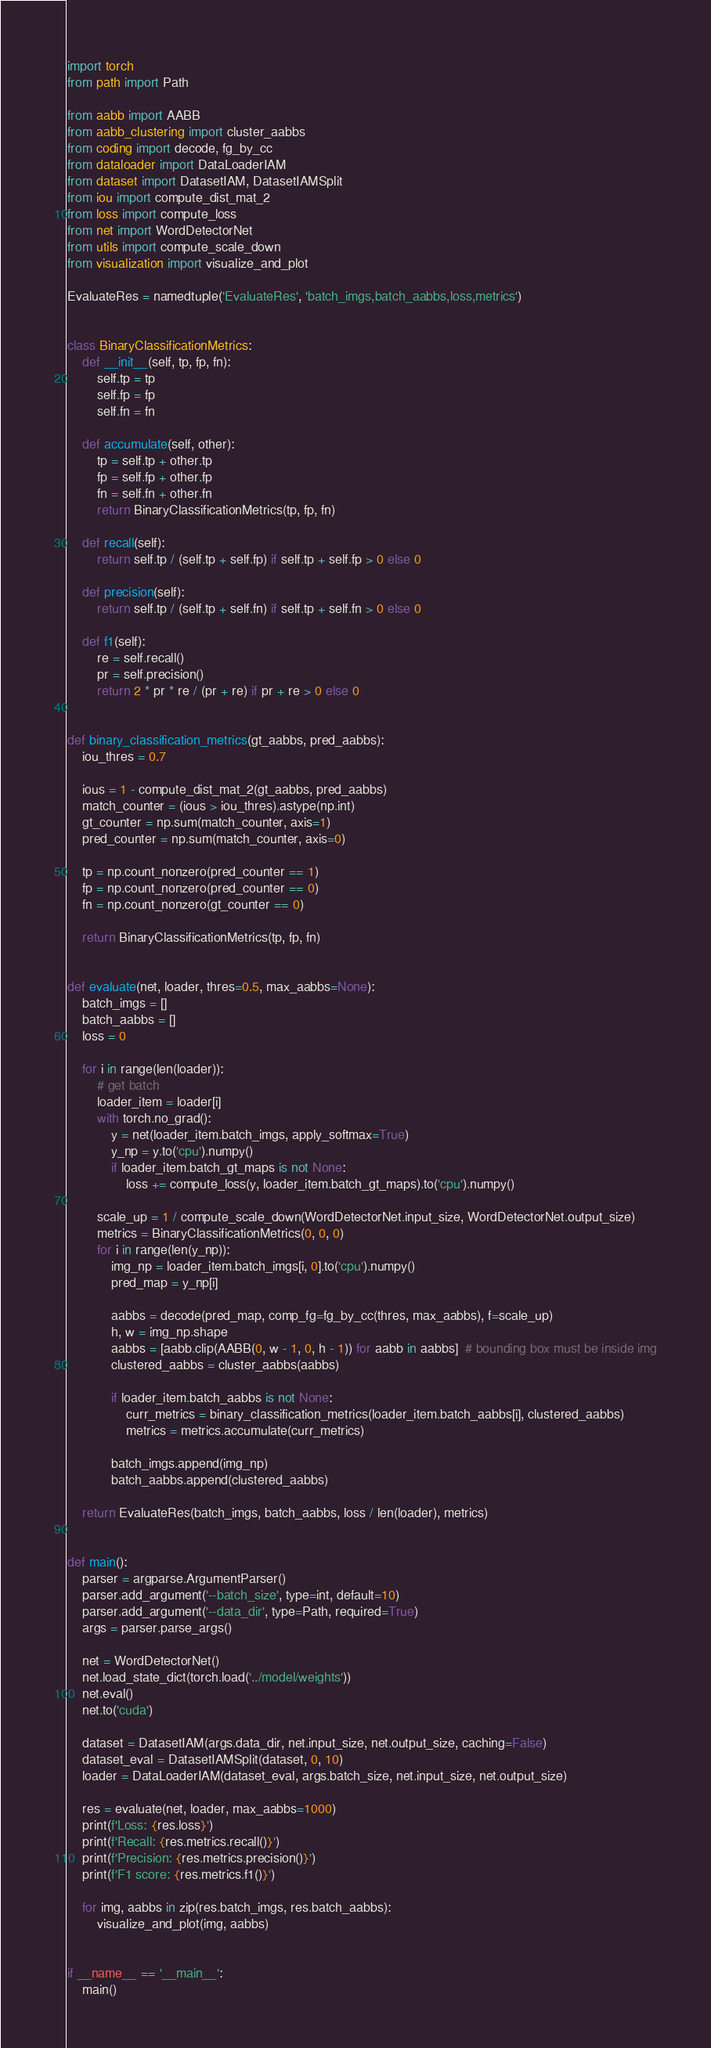<code> <loc_0><loc_0><loc_500><loc_500><_Python_>import torch
from path import Path

from aabb import AABB
from aabb_clustering import cluster_aabbs
from coding import decode, fg_by_cc
from dataloader import DataLoaderIAM
from dataset import DatasetIAM, DatasetIAMSplit
from iou import compute_dist_mat_2
from loss import compute_loss
from net import WordDetectorNet
from utils import compute_scale_down
from visualization import visualize_and_plot

EvaluateRes = namedtuple('EvaluateRes', 'batch_imgs,batch_aabbs,loss,metrics')


class BinaryClassificationMetrics:
    def __init__(self, tp, fp, fn):
        self.tp = tp
        self.fp = fp
        self.fn = fn

    def accumulate(self, other):
        tp = self.tp + other.tp
        fp = self.fp + other.fp
        fn = self.fn + other.fn
        return BinaryClassificationMetrics(tp, fp, fn)

    def recall(self):
        return self.tp / (self.tp + self.fp) if self.tp + self.fp > 0 else 0

    def precision(self):
        return self.tp / (self.tp + self.fn) if self.tp + self.fn > 0 else 0

    def f1(self):
        re = self.recall()
        pr = self.precision()
        return 2 * pr * re / (pr + re) if pr + re > 0 else 0


def binary_classification_metrics(gt_aabbs, pred_aabbs):
    iou_thres = 0.7

    ious = 1 - compute_dist_mat_2(gt_aabbs, pred_aabbs)
    match_counter = (ious > iou_thres).astype(np.int)
    gt_counter = np.sum(match_counter, axis=1)
    pred_counter = np.sum(match_counter, axis=0)

    tp = np.count_nonzero(pred_counter == 1)
    fp = np.count_nonzero(pred_counter == 0)
    fn = np.count_nonzero(gt_counter == 0)

    return BinaryClassificationMetrics(tp, fp, fn)


def evaluate(net, loader, thres=0.5, max_aabbs=None):
    batch_imgs = []
    batch_aabbs = []
    loss = 0

    for i in range(len(loader)):
        # get batch
        loader_item = loader[i]
        with torch.no_grad():
            y = net(loader_item.batch_imgs, apply_softmax=True)
            y_np = y.to('cpu').numpy()
            if loader_item.batch_gt_maps is not None:
                loss += compute_loss(y, loader_item.batch_gt_maps).to('cpu').numpy()

        scale_up = 1 / compute_scale_down(WordDetectorNet.input_size, WordDetectorNet.output_size)
        metrics = BinaryClassificationMetrics(0, 0, 0)
        for i in range(len(y_np)):
            img_np = loader_item.batch_imgs[i, 0].to('cpu').numpy()
            pred_map = y_np[i]

            aabbs = decode(pred_map, comp_fg=fg_by_cc(thres, max_aabbs), f=scale_up)
            h, w = img_np.shape
            aabbs = [aabb.clip(AABB(0, w - 1, 0, h - 1)) for aabb in aabbs]  # bounding box must be inside img
            clustered_aabbs = cluster_aabbs(aabbs)

            if loader_item.batch_aabbs is not None:
                curr_metrics = binary_classification_metrics(loader_item.batch_aabbs[i], clustered_aabbs)
                metrics = metrics.accumulate(curr_metrics)

            batch_imgs.append(img_np)
            batch_aabbs.append(clustered_aabbs)

    return EvaluateRes(batch_imgs, batch_aabbs, loss / len(loader), metrics)


def main():
    parser = argparse.ArgumentParser()
    parser.add_argument('--batch_size', type=int, default=10)
    parser.add_argument('--data_dir', type=Path, required=True)
    args = parser.parse_args()

    net = WordDetectorNet()
    net.load_state_dict(torch.load('../model/weights'))
    net.eval()
    net.to('cuda')

    dataset = DatasetIAM(args.data_dir, net.input_size, net.output_size, caching=False)
    dataset_eval = DatasetIAMSplit(dataset, 0, 10)
    loader = DataLoaderIAM(dataset_eval, args.batch_size, net.input_size, net.output_size)

    res = evaluate(net, loader, max_aabbs=1000)
    print(f'Loss: {res.loss}')
    print(f'Recall: {res.metrics.recall()}')
    print(f'Precision: {res.metrics.precision()}')
    print(f'F1 score: {res.metrics.f1()}')

    for img, aabbs in zip(res.batch_imgs, res.batch_aabbs):
        visualize_and_plot(img, aabbs)


if __name__ == '__main__':
    main()
</code> 